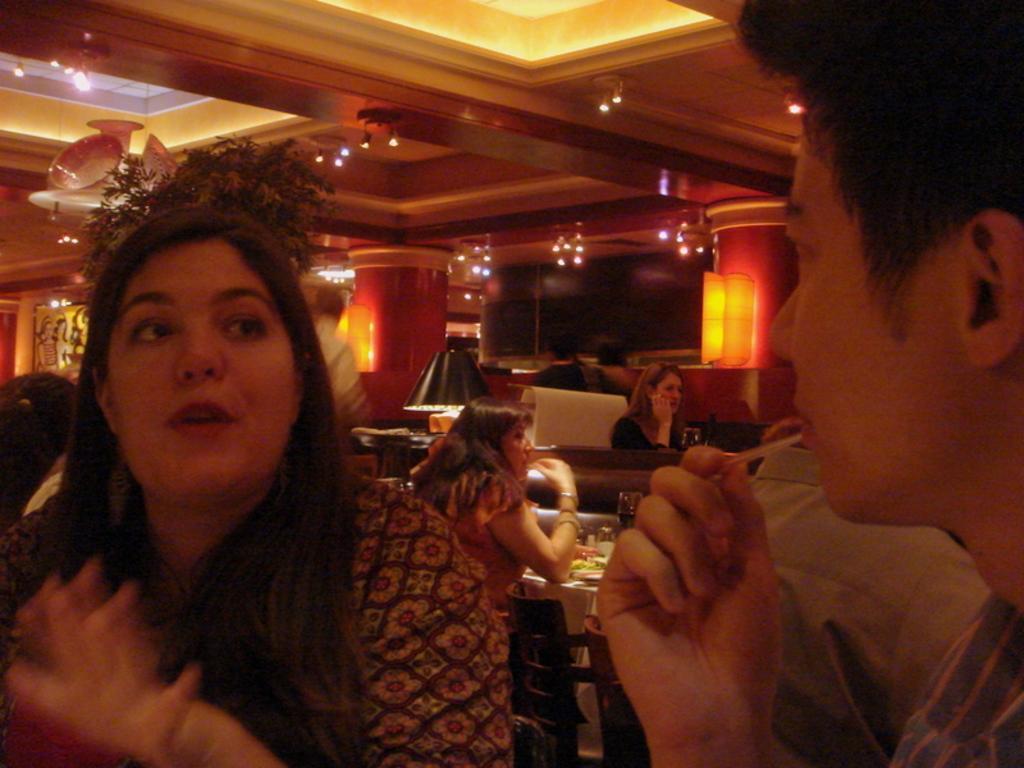Can you describe this image briefly? In this image we can see electric lights, wall hangings, bed lamp, tables, glass tumblers, food, chairs and persons sitting on the chairs. 